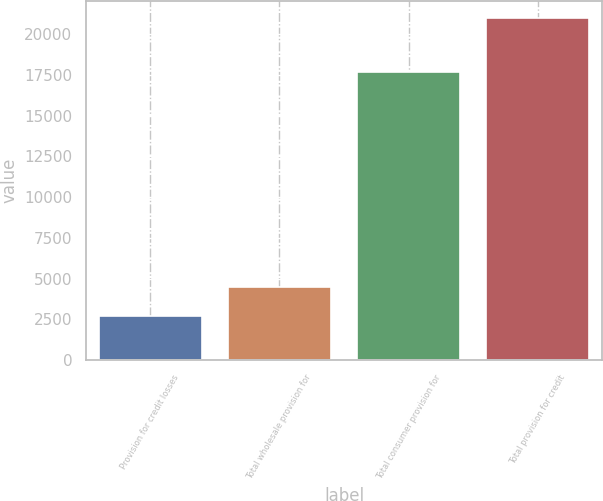<chart> <loc_0><loc_0><loc_500><loc_500><bar_chart><fcel>Provision for credit losses<fcel>Total wholesale provision for<fcel>Total consumer provision for<fcel>Total provision for credit<nl><fcel>2681<fcel>4510.8<fcel>17652<fcel>20979<nl></chart> 